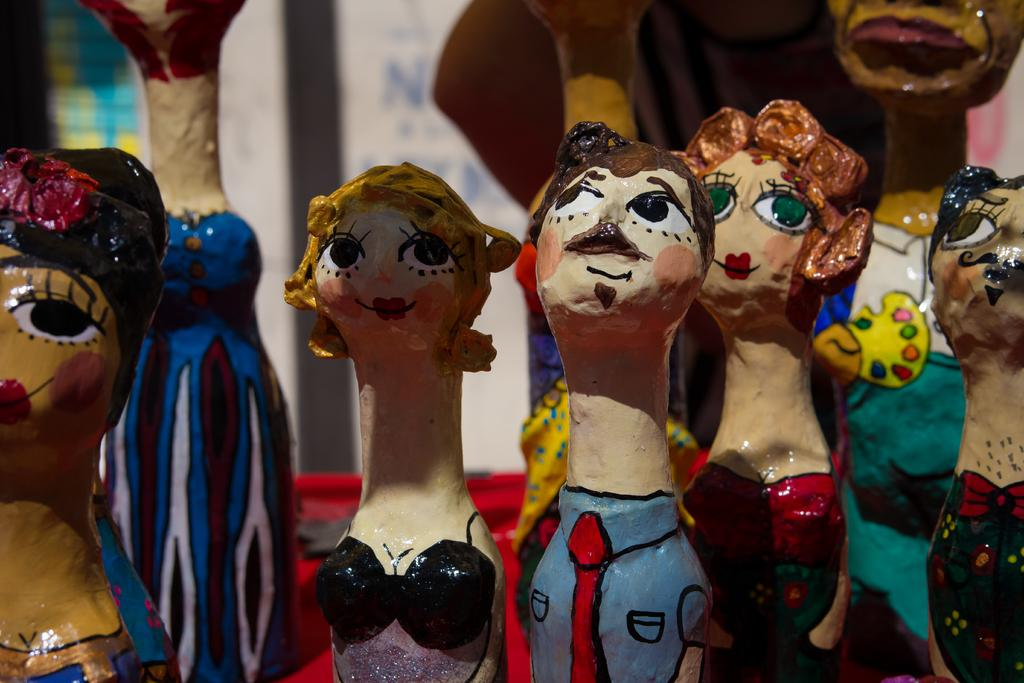What objects can be seen in the image? There are toys in the image. Can you describe the background of the image? The background of the image is blurred. What type of blade can be seen in the image? There is no blade present in the image; it features toys and a blurred background. How much tax is being paid for the toys in the image? There is no indication of tax or any financial transaction in the image, as it only shows toys and a blurred background. 